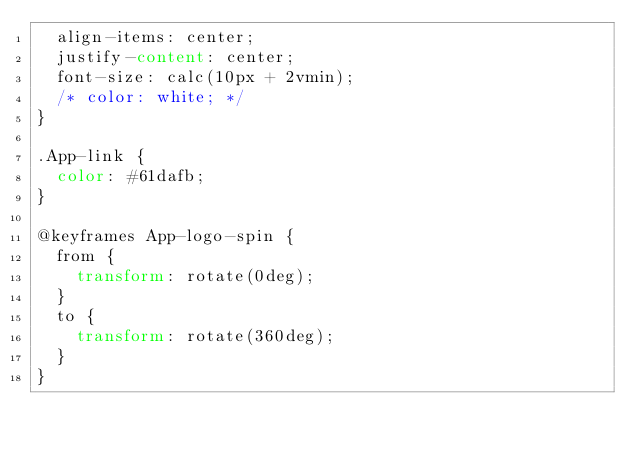Convert code to text. <code><loc_0><loc_0><loc_500><loc_500><_CSS_>  align-items: center;
  justify-content: center;
  font-size: calc(10px + 2vmin);
  /* color: white; */
}

.App-link {
  color: #61dafb;
}

@keyframes App-logo-spin {
  from {
    transform: rotate(0deg);
  }
  to {
    transform: rotate(360deg);
  }
}
</code> 